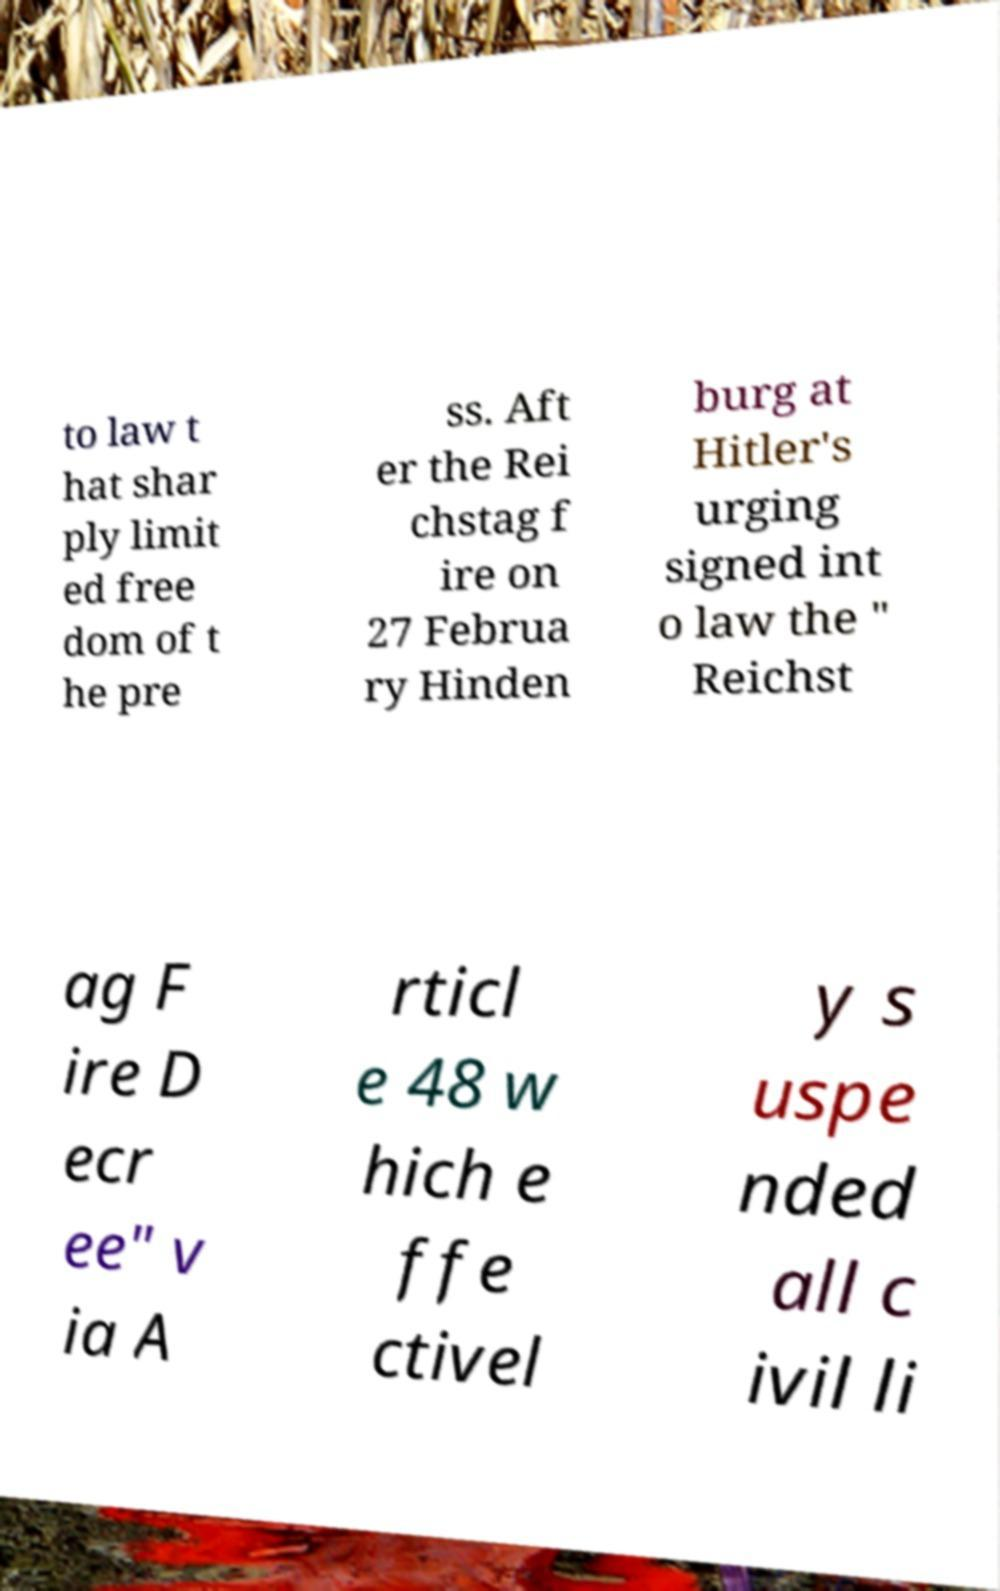For documentation purposes, I need the text within this image transcribed. Could you provide that? to law t hat shar ply limit ed free dom of t he pre ss. Aft er the Rei chstag f ire on 27 Februa ry Hinden burg at Hitler's urging signed int o law the " Reichst ag F ire D ecr ee" v ia A rticl e 48 w hich e ffe ctivel y s uspe nded all c ivil li 